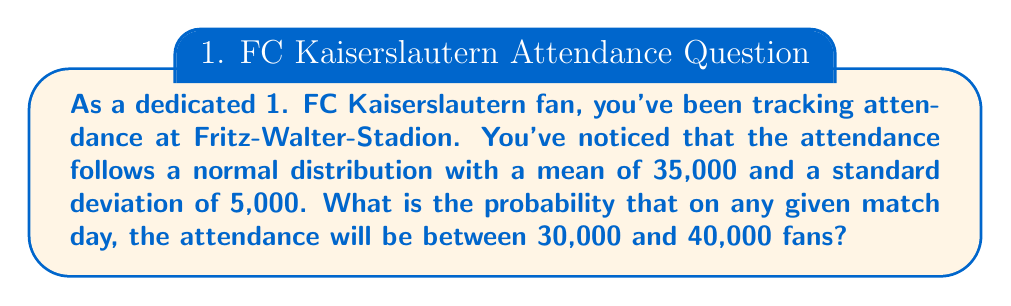Could you help me with this problem? To solve this problem, we need to use the properties of the normal distribution and the concept of z-scores. Let's break it down step-by-step:

1) We're given that the attendance follows a normal distribution with:
   $\mu = 35,000$ (mean)
   $\sigma = 5,000$ (standard deviation)

2) We want to find the probability that attendance is between 30,000 and 40,000.

3) To use the standard normal distribution table, we need to convert these values to z-scores:

   For 30,000: $z_1 = \frac{30,000 - 35,000}{5,000} = -1$
   For 40,000: $z_2 = \frac{40,000 - 35,000}{5,000} = 1$

4) Now, we need to find $P(-1 \leq Z \leq 1)$, where Z is the standard normal random variable.

5) This probability can be calculated as:
   $P(-1 \leq Z \leq 1) = P(Z \leq 1) - P(Z \leq -1)$

6) Using a standard normal distribution table or calculator:
   $P(Z \leq 1) \approx 0.8413$
   $P(Z \leq -1) \approx 0.1587$

7) Therefore:
   $P(-1 \leq Z \leq 1) = 0.8413 - 0.1587 = 0.6826$

8) Convert to a percentage: $0.6826 \times 100\% = 68.26\%$

This means there's approximately a 68.26% chance that the attendance will be between 30,000 and 40,000 fans on any given match day.
Answer: $68.26\%$ 